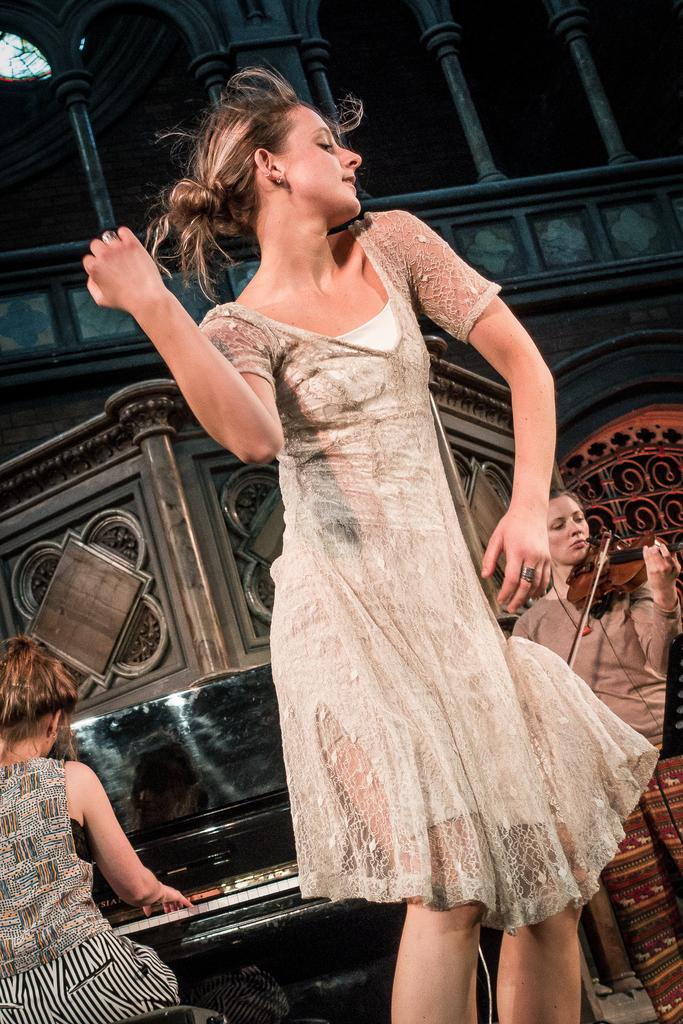What is the woman in the image wearing? The woman in the image is wearing a white dress. How many other women are in the image? There are two other women in the image. What are the two other women doing in the image? The two other women are playing musical instruments. Where does the scene take place? The scene takes place on a stage. What type of jewel is the woman wearing on her head in the image? There is no jewel visible on the woman's head in the image. What is the minister doing in the image? There is no minister present in the image. 